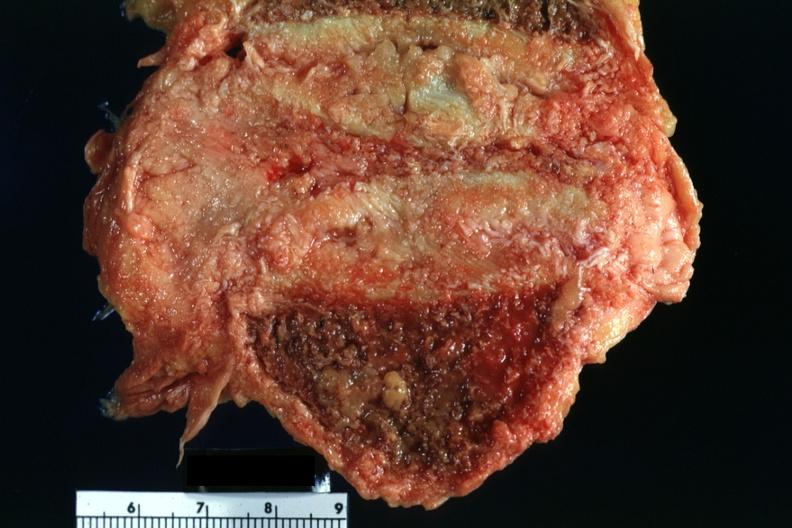what does this image show?
Answer the question using a single word or phrase. Close-up of collapsed vertebral body with tumor rather easily seen 